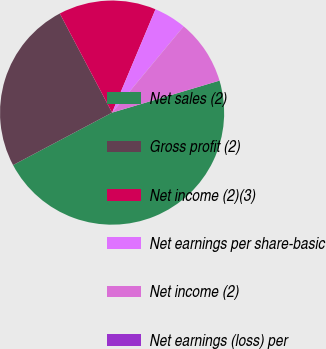Convert chart to OTSL. <chart><loc_0><loc_0><loc_500><loc_500><pie_chart><fcel>Net sales (2)<fcel>Gross profit (2)<fcel>Net income (2)(3)<fcel>Net earnings per share-basic<fcel>Net income (2)<fcel>Net earnings (loss) per<nl><fcel>46.86%<fcel>25.03%<fcel>14.06%<fcel>4.69%<fcel>9.37%<fcel>0.0%<nl></chart> 